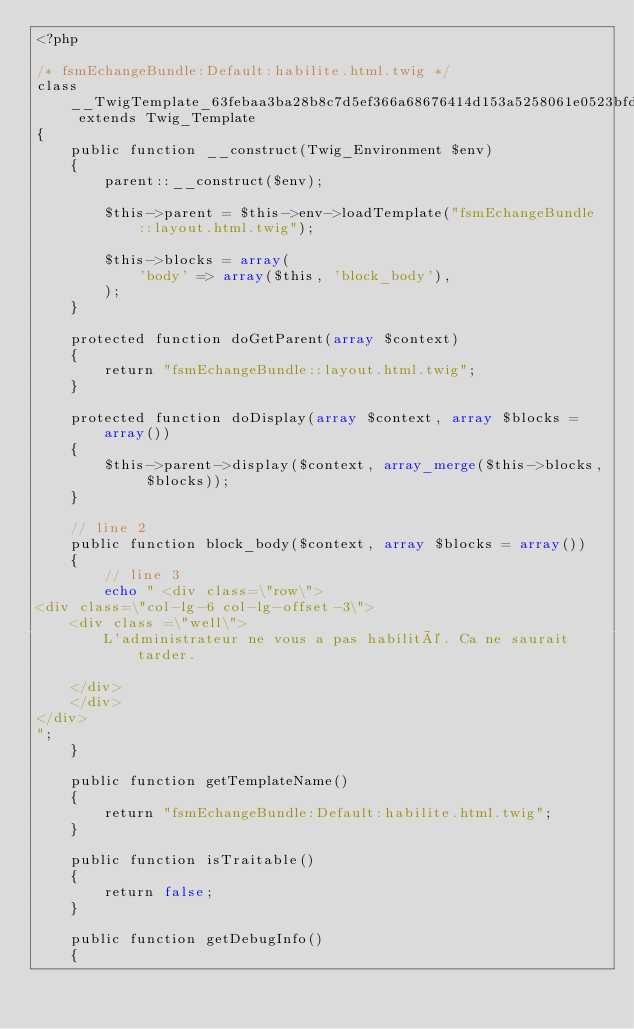<code> <loc_0><loc_0><loc_500><loc_500><_PHP_><?php

/* fsmEchangeBundle:Default:habilite.html.twig */
class __TwigTemplate_63febaa3ba28b8c7d5ef366a68676414d153a5258061e0523bfd4905673584b9 extends Twig_Template
{
    public function __construct(Twig_Environment $env)
    {
        parent::__construct($env);

        $this->parent = $this->env->loadTemplate("fsmEchangeBundle::layout.html.twig");

        $this->blocks = array(
            'body' => array($this, 'block_body'),
        );
    }

    protected function doGetParent(array $context)
    {
        return "fsmEchangeBundle::layout.html.twig";
    }

    protected function doDisplay(array $context, array $blocks = array())
    {
        $this->parent->display($context, array_merge($this->blocks, $blocks));
    }

    // line 2
    public function block_body($context, array $blocks = array())
    {
        // line 3
        echo " <div class=\"row\">
<div class=\"col-lg-6 col-lg-offset-3\">
    <div class =\"well\">
        L'administrateur ne vous a pas habilité. Ca ne saurait tarder.
        
    </div>
    </div>
</div>
";
    }

    public function getTemplateName()
    {
        return "fsmEchangeBundle:Default:habilite.html.twig";
    }

    public function isTraitable()
    {
        return false;
    }

    public function getDebugInfo()
    {</code> 